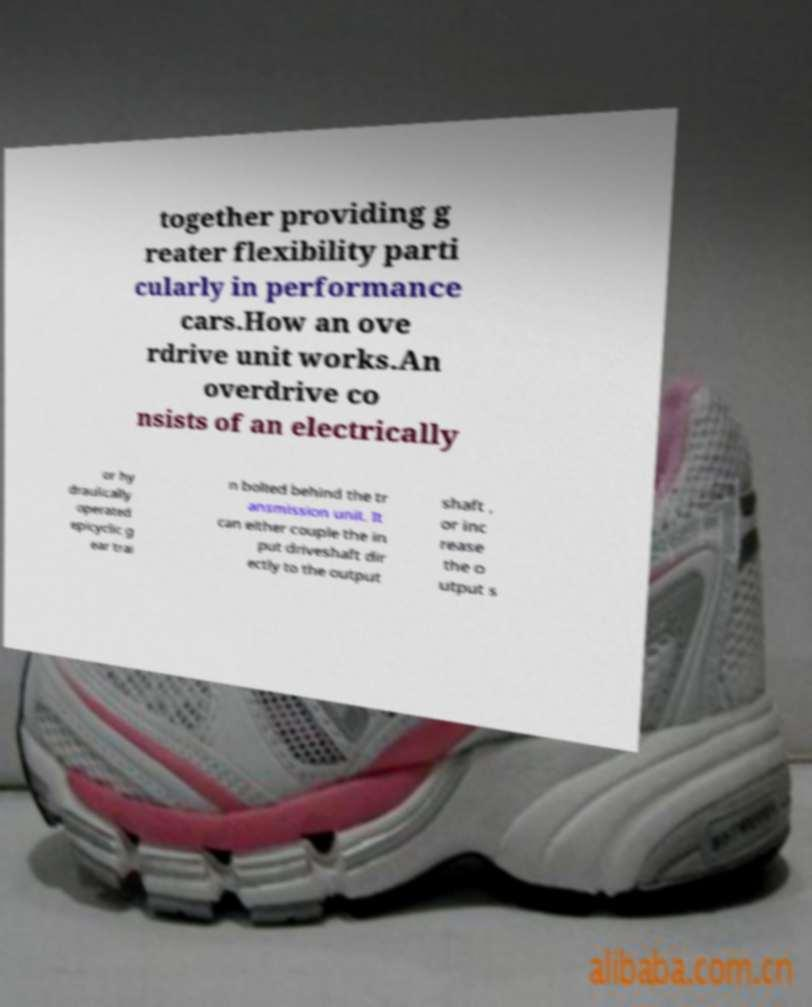There's text embedded in this image that I need extracted. Can you transcribe it verbatim? together providing g reater flexibility parti cularly in performance cars.How an ove rdrive unit works.An overdrive co nsists of an electrically or hy draulically operated epicyclic g ear trai n bolted behind the tr ansmission unit. It can either couple the in put driveshaft dir ectly to the output shaft , or inc rease the o utput s 